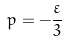Convert formula to latex. <formula><loc_0><loc_0><loc_500><loc_500>p = - { \frac { \varepsilon } { 3 } }</formula> 